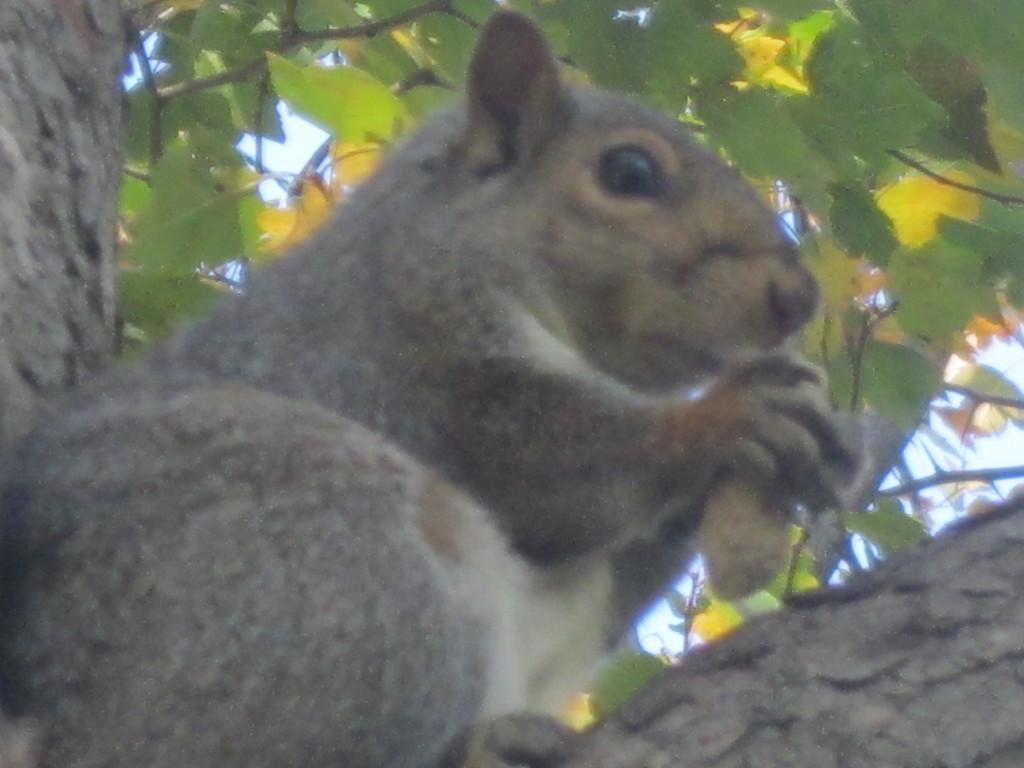Please provide a concise description of this image. In this picture there is a squirrel holding an object is sitting and there are few leaves above it. 